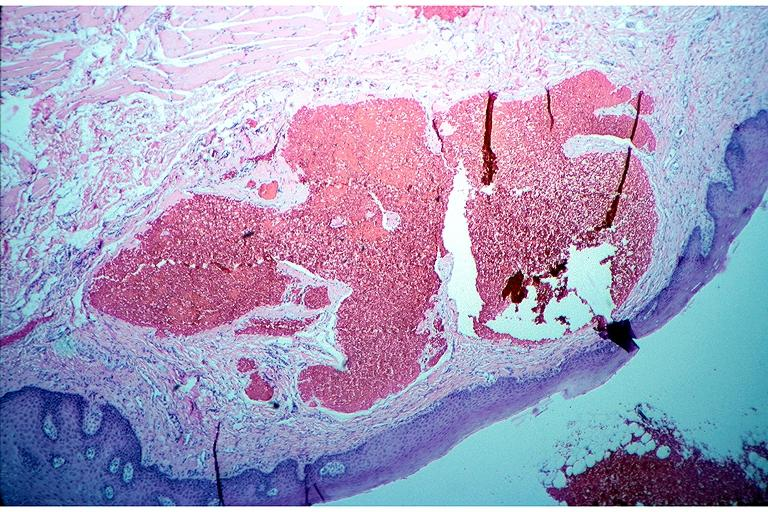s vasculitis foreign body present?
Answer the question using a single word or phrase. No 